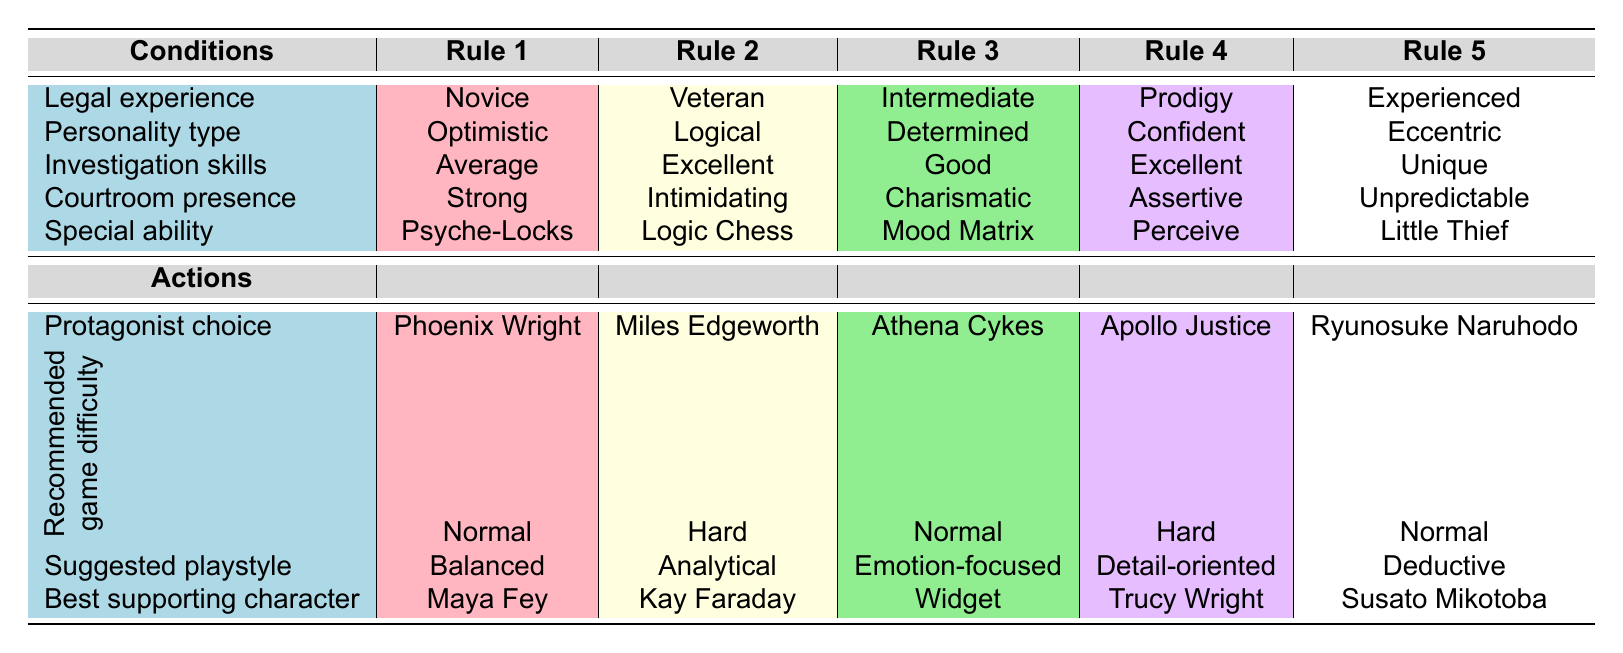What protagonist choice is recommended for a character with "Excellent" investigation skills? Looking at the "Investigation skills" column, "Excellent" corresponds to two rows: "Miles Edgeworth" and "Apollo Justice." Both options are valid, but to find a single answer, I can also look at the other characteristics of these protagonists. "Miles Edgeworth" is a Veteran with a "Logical" personality type, while "Apollo Justice" is a Prodigy with a "Confident" personality type. The answer to the protagonist choice for "Excellent" investigation skills can be either based on preferences.
Answer: Miles Edgeworth or Apollo Justice Is "Ryunosuke Naruhodo" best supported by "Maya Fey"? From the table, "Ryunosuke Naruhodo" is listed as having "Susato Mikotoba" as the best supporting character, and "Maya Fey" is linked with "Phoenix Wright." Therefore, it confirms that "Maya Fey" is not the best supporting character for "Ryunosuke Naruhodo."
Answer: No Which protagonist has the strongest courtroom presence? The "Courtroom presence" column shows "Assertive" for "Apollo Justice," "Strong" for "Phoenix Wright," "Intimidating" for "Miles Edgeworth," "Charismatic" for "Athena Cykes," and "Unpredictable" for "Ryunosuke Naruhodo." The strongest descriptor is subjective, so "Intimidating" for "Miles Edgeworth" suggests he has the strongest presence in a courtroom setting.
Answer: Miles Edgeworth What is the most common recommended game difficulty across all protagonists? Analyzing the "Recommended game difficulty," we have "Normal" for Phoenix Wright, Athena Cykes, and Ryunosuke Naruhodo. "Hard" is for Miles Edgeworth and Apollo Justice. Thus, the majority (3 out of 5) suggests that "Normal" is the most common game difficulty recommended.
Answer: Normal Which character is suggested for a player who values a deductive playstyle? The "Suggested playstyle" column indicates "Deductive" corresponds to "Ryunosuke Naruhodo." Checking the other characters reveals the playstyle varies among the protagonists: balanced, analytical, emotion-focused, and detail-oriented are used by others. Hence, anyone preferring a deductive playstyle should choose "Ryunosuke Naruhodo."
Answer: Ryunosuke Naruhodo What are the characteristics of a character with "Eccentric" personality type? The "Eccentric" personality type corresponds to "Ryunosuke Naruhodo" who, according to the table, has "Experienced" legal experience, "Unique" investigation skills, "Unpredictable" courtroom presence, and the special ability "Little Thief." Thus the characteristics indicate him as someone with creative, unpredictable attributes suitable for quirky scenarios.
Answer: Experienced, Unique, Unpredictable, Little Thief 